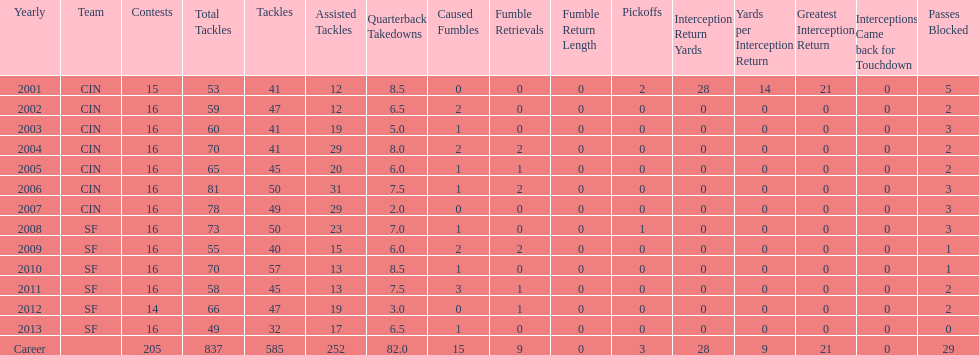What is the only season he has fewer than three sacks? 2007. 